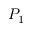Convert formula to latex. <formula><loc_0><loc_0><loc_500><loc_500>P _ { 1 }</formula> 